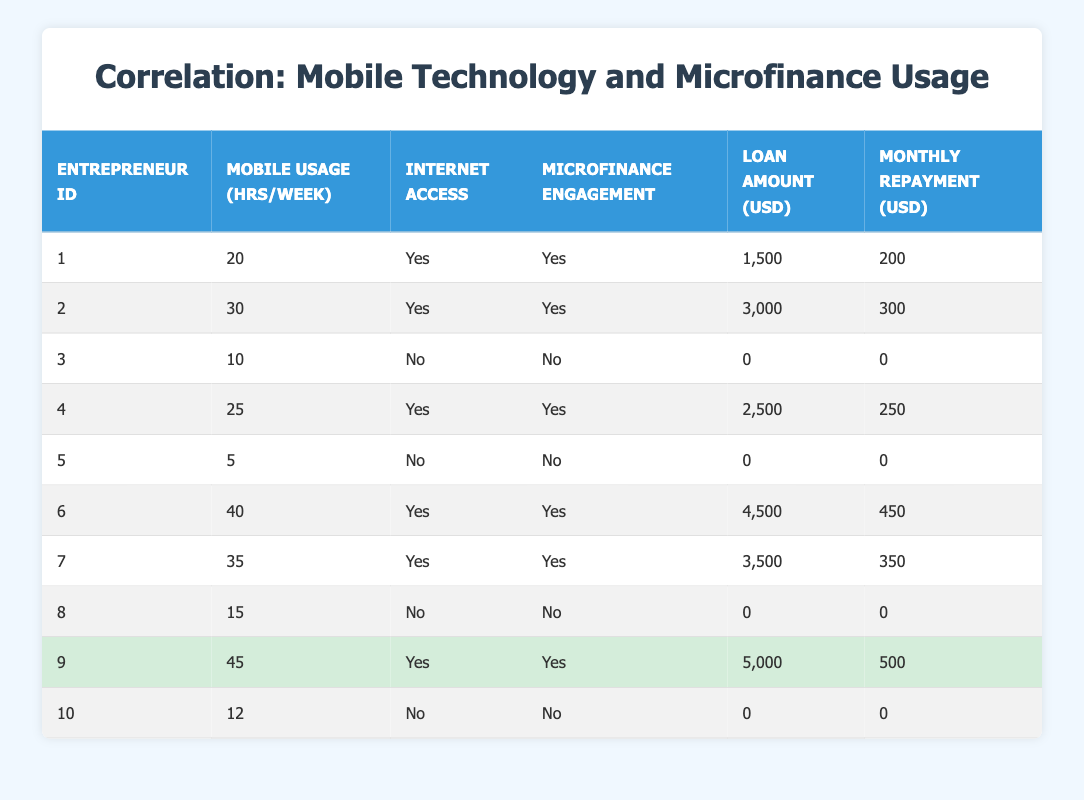What is the maximum loan amount received by an entrepreneur in the data? Looking through the Loan Amount (USD) column, the highest value is 5000 from Entrepreneur ID 9.
Answer: 5000 Which entrepreneurs have access to the internet but did not engage with microfinance? Filter the table for entrepreneurs with 'Yes' under Access to Internet and 'No' under Microfinance Engagement. None have those characteristics in the data.
Answer: None What is the total monthly repayment amount from all entrepreneurs who engage in microfinance? Summing the Monthly Repayment Amount (USD) for those with Microfinance Engagement as 'Yes' gives us 200 + 300 + 250 + 450 + 350 + 500 = 2050.
Answer: 2050 Is there any entrepreneur who does not use mobile technology but engages in microfinance? Looking at the Mobile Usage (hrs/week) column, all entrepreneurs who engage in microfinance have mobile usage hours greater than 0.
Answer: No What is the average mobile usage hours per week for entrepreneurs who access the internet? For those with Access to Internet as 'Yes', the hours per week are 20, 30, 25, 40, 35, and 45. The total is 20 + 30 + 25 + 40 + 35 + 45 = 195. Dividing by the 6 entrepreneurs gives an average of 195/6 = 32.5.
Answer: 32.5 How many entrepreneurs borrowed more than $4000? Scanning the Loan Amount (USD) column, only Entrepreneur ID 6 (4500) and Entrepreneur ID 9 (5000) qualify as more than 4000. Thus, there are 2 such entrepreneurs.
Answer: 2 What is the relationship between the number of hours of mobile usage and engagement with microfinance? To analyze this, count how many entrepreneurs with various Mobile Usage hours also engaged in microfinance. There are 6 out of 10 total entrepreneurs, indicating a positive correlation.
Answer: Positive correlation Which entrepreneur has the least mobile usage hours and what is their microfinance engagement status? Entrepreneur ID 5 has the least mobile usage hours at 5 hours a week and their microfinance engagement status is 'No'.
Answer: Entrepreneur ID 5, No 